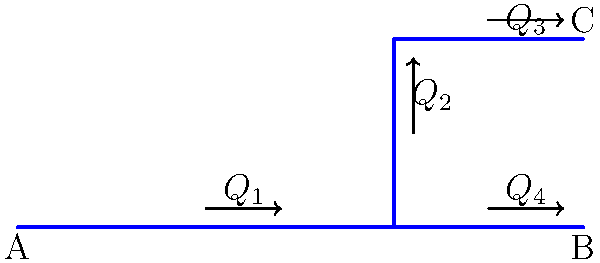In the pipe system shown above, water flows from point A to points B and C. Given that $Q_1 = 100$ L/min, $Q_2 = 40$ L/min, and $Q_3 = 25$ L/min, estimate the flow rate $Q_4$ in L/min. Assume no water loss in the system. To solve this problem, we'll use the principle of conservation of mass, which in this case translates to conservation of flow rate. Let's approach this step-by-step:

1. At the first junction (where the pipe splits vertically):
   $Q_1 = Q_2 + Q_{horizontal}$
   Where $Q_{horizontal}$ is the flow rate in the bottom horizontal pipe.

2. At the second junction (where the pipe splits to B and C):
   $Q_{horizontal} = Q_3 + Q_4$

3. We know:
   $Q_1 = 100$ L/min
   $Q_2 = 40$ L/min
   $Q_3 = 25$ L/min

4. From step 1:
   $Q_{horizontal} = Q_1 - Q_2 = 100 - 40 = 60$ L/min

5. From step 2:
   $Q_4 = Q_{horizontal} - Q_3 = 60 - 25 = 35$ L/min

Therefore, the flow rate $Q_4$ is 35 L/min.
Answer: $Q_4 = 35$ L/min 